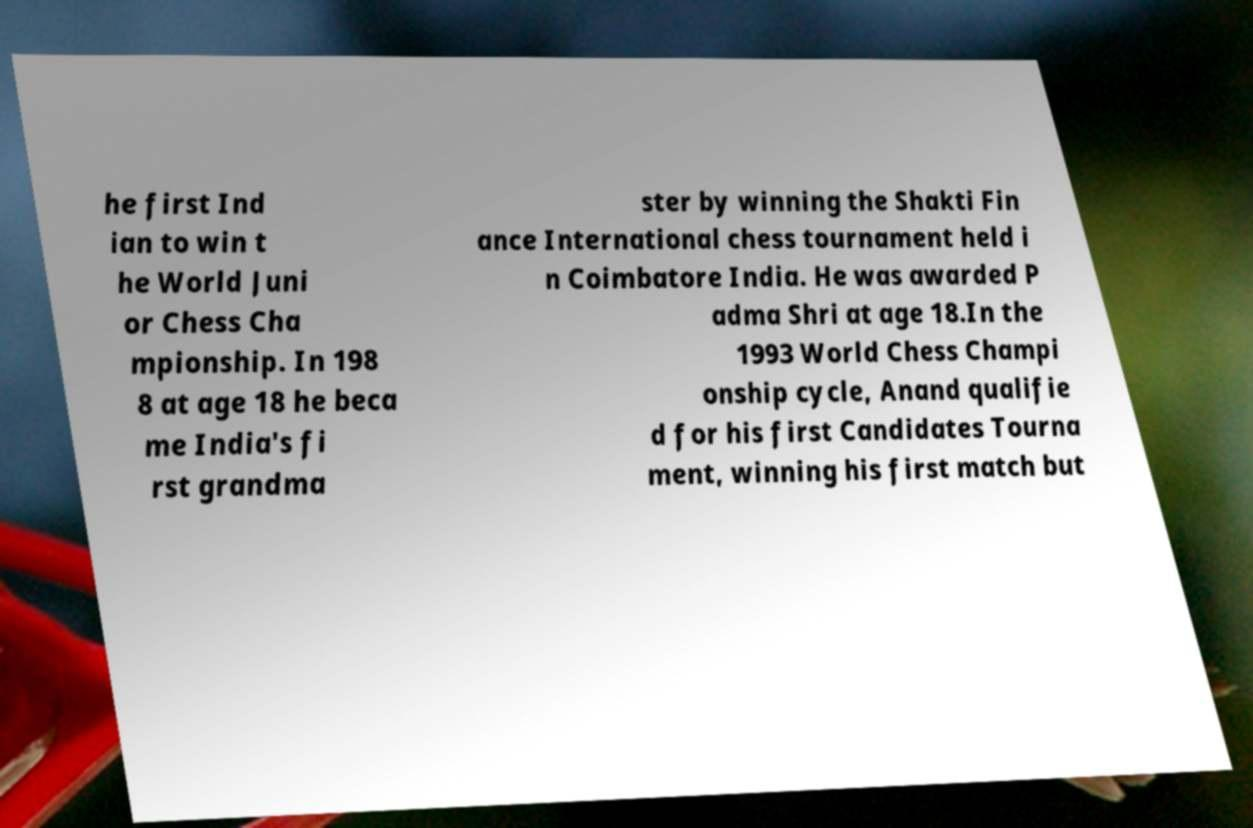Can you accurately transcribe the text from the provided image for me? he first Ind ian to win t he World Juni or Chess Cha mpionship. In 198 8 at age 18 he beca me India's fi rst grandma ster by winning the Shakti Fin ance International chess tournament held i n Coimbatore India. He was awarded P adma Shri at age 18.In the 1993 World Chess Champi onship cycle, Anand qualifie d for his first Candidates Tourna ment, winning his first match but 